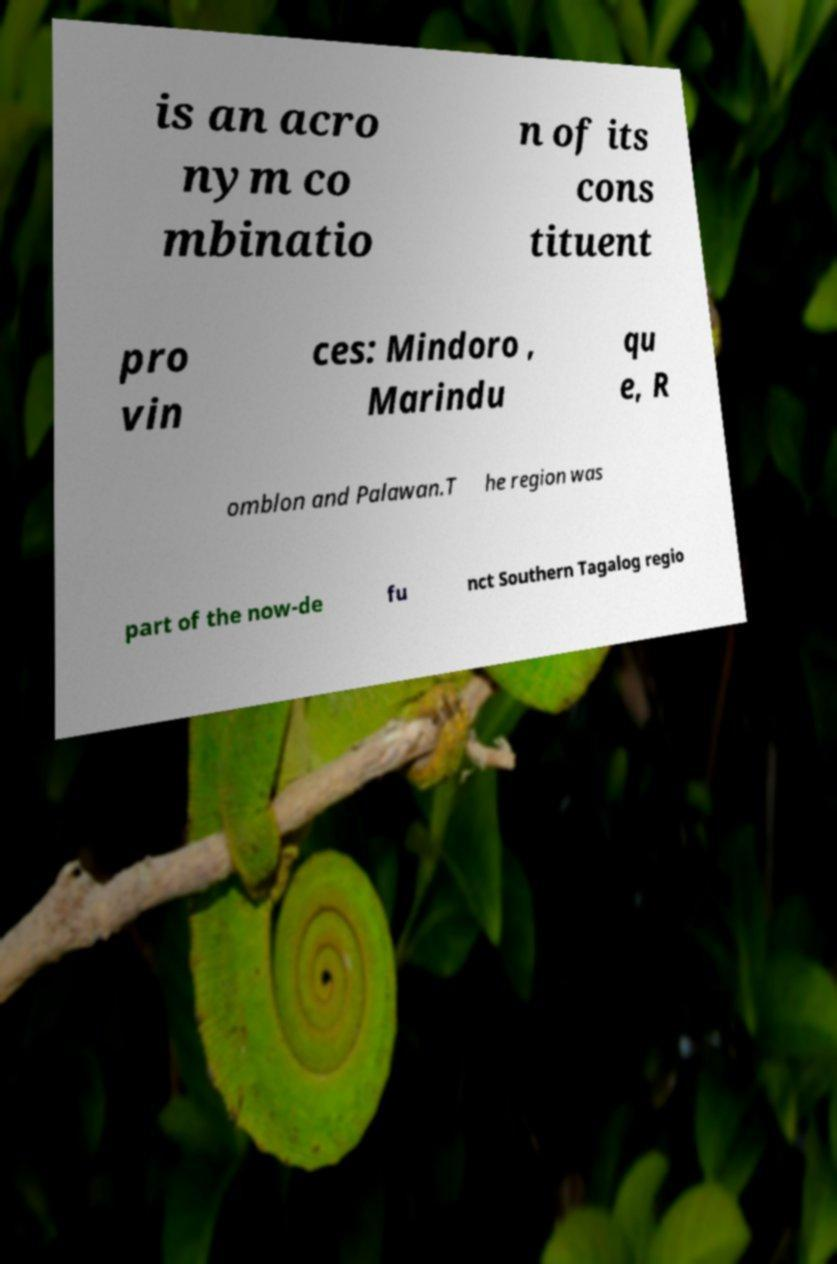I need the written content from this picture converted into text. Can you do that? is an acro nym co mbinatio n of its cons tituent pro vin ces: Mindoro , Marindu qu e, R omblon and Palawan.T he region was part of the now-de fu nct Southern Tagalog regio 